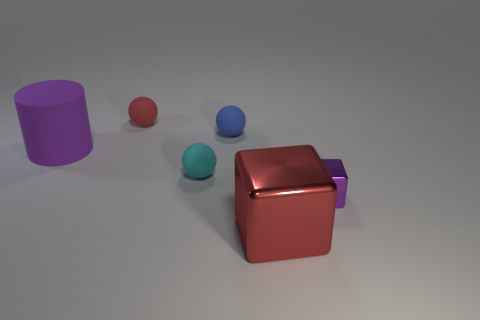There is a cylinder that is the same color as the small shiny cube; what size is it?
Provide a short and direct response. Large. There is a red rubber sphere; does it have the same size as the shiny cube that is right of the red metallic object?
Offer a terse response. Yes. What number of cylinders are red rubber objects or tiny purple objects?
Provide a short and direct response. 0. There is a cylinder that is the same material as the small cyan sphere; what size is it?
Your answer should be compact. Large. There is a red thing that is behind the tiny blue sphere; is it the same size as the sphere in front of the big matte object?
Keep it short and to the point. Yes. What number of things are either yellow rubber cylinders or small purple objects?
Your response must be concise. 1. There is a blue thing; what shape is it?
Keep it short and to the point. Sphere. There is a cyan object that is the same shape as the blue object; what is its size?
Keep it short and to the point. Small. Are there any other things that are made of the same material as the tiny cyan ball?
Give a very brief answer. Yes. There is a red thing that is to the right of the matte ball behind the small blue rubber ball; what size is it?
Your response must be concise. Large. 